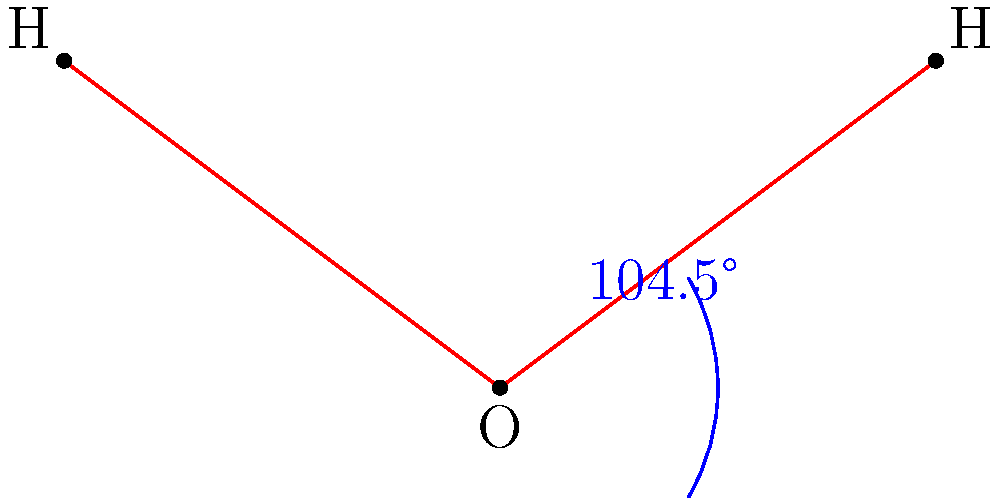Which of the following best describes the arrangement of atoms in a water molecule?

A) Three atoms in a straight line
B) Three atoms forming an equilateral triangle
C) Two hydrogen atoms and one oxygen atom forming a V-shape
D) One hydrogen atom between two oxygen atoms Let's break this down step-by-step:

1. A water molecule consists of two hydrogen atoms and one oxygen atom.

2. In the diagram, we can see:
   - A central atom labeled "O" (oxygen)
   - Two outer atoms labeled "H" (hydrogen)

3. The arrangement is not linear (straight line), ruling out option A.

4. The atoms do not form an equilateral triangle, eliminating option B.

5. We can see that the two hydrogen atoms are connected to the oxygen atom, forming a V-shape. This matches option C.

6. Option D is incorrect because water has only one oxygen atom, not two.

7. The angle between the two hydrogen atoms is shown to be 104.5°, which is characteristic of the V-shape in water molecules.

Therefore, based on the diagram and our understanding of water molecules, the correct arrangement is a V-shape with two hydrogen atoms and one oxygen atom.
Answer: C) Two hydrogen atoms and one oxygen atom forming a V-shape 